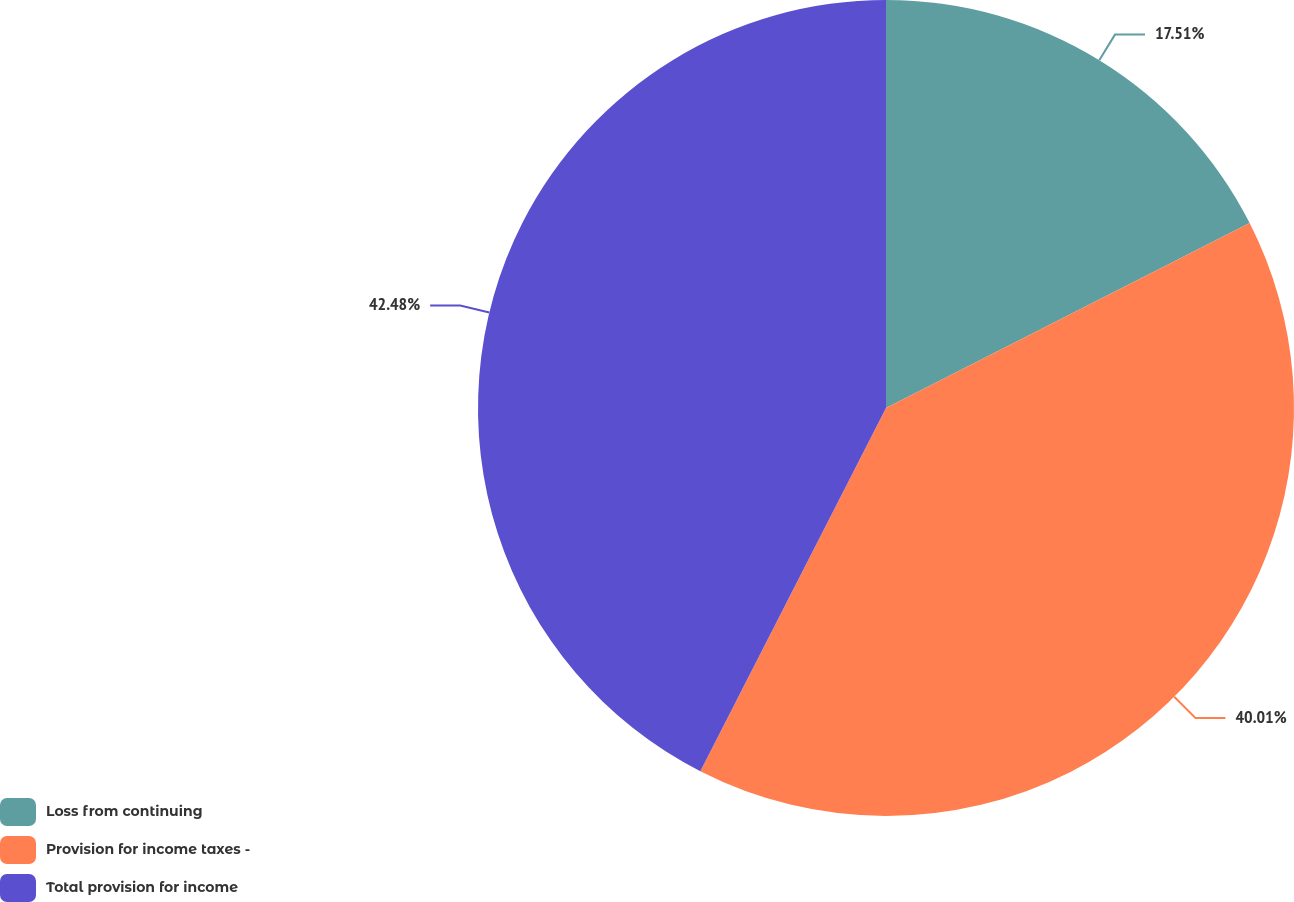<chart> <loc_0><loc_0><loc_500><loc_500><pie_chart><fcel>Loss from continuing<fcel>Provision for income taxes -<fcel>Total provision for income<nl><fcel>17.51%<fcel>40.01%<fcel>42.48%<nl></chart> 